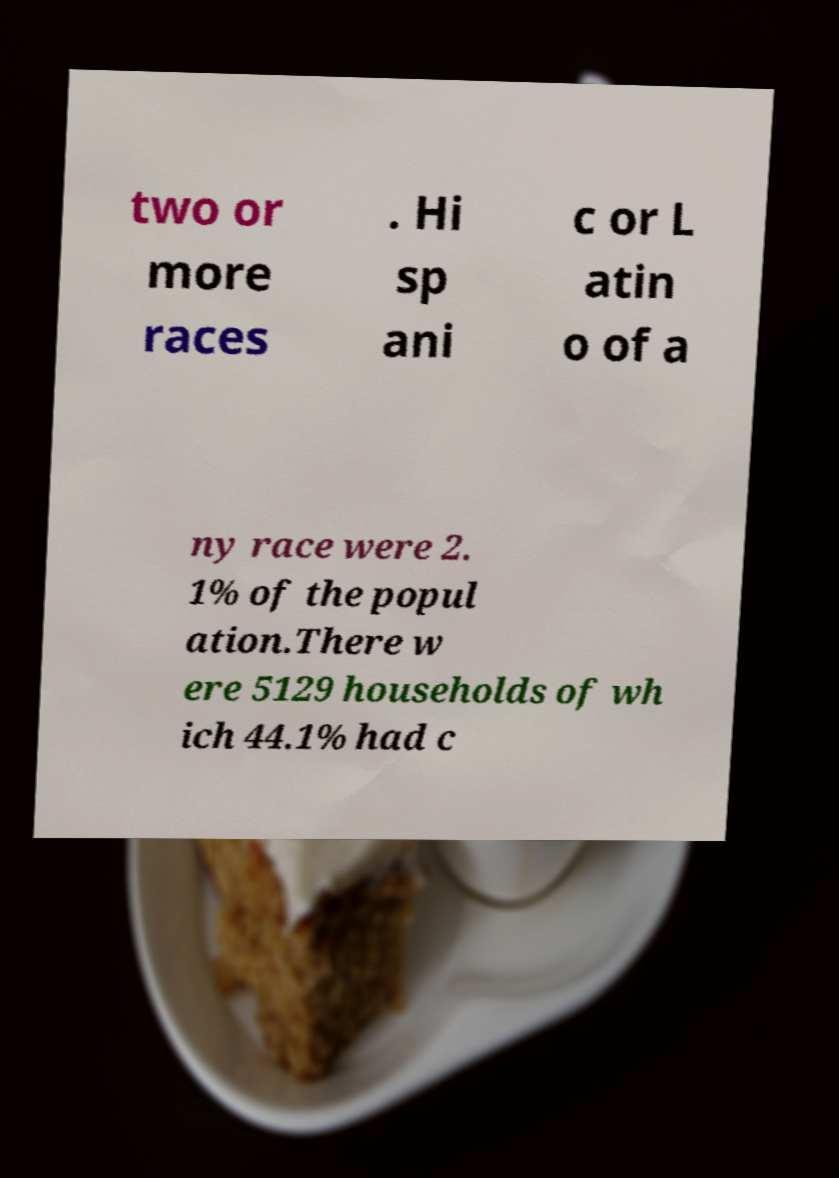Please identify and transcribe the text found in this image. two or more races . Hi sp ani c or L atin o of a ny race were 2. 1% of the popul ation.There w ere 5129 households of wh ich 44.1% had c 